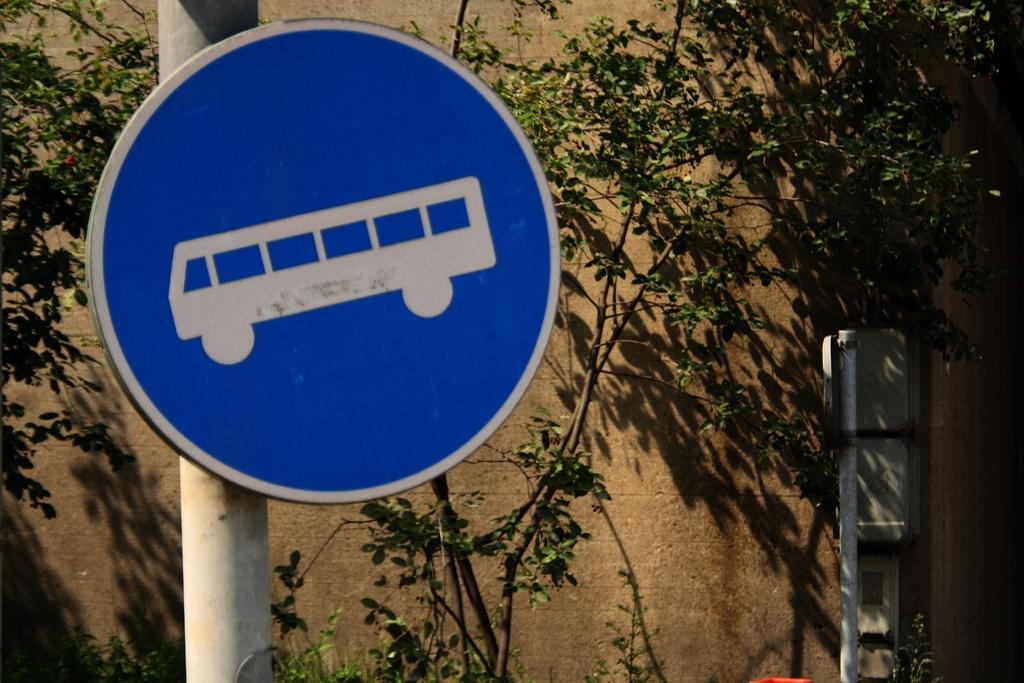What is the main object in the foreground of the image? There is a sign board in the image. How is the sign board positioned in the image? The sign board is attached to a pole. What can be seen in the background of the image? There are trees, a wall, and other objects visible in the background of the image. What type of marble is used to create the sign board in the image? There is no mention of marble being used to create the sign board in the image. The sign board is simply attached to a pole. What is the purpose of the dime in the image? There is no dime present in the image. 